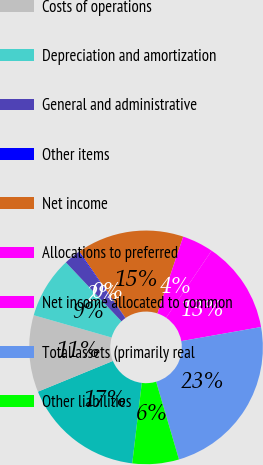Convert chart to OTSL. <chart><loc_0><loc_0><loc_500><loc_500><pie_chart><fcel>Total revenue<fcel>Costs of operations<fcel>Depreciation and amortization<fcel>General and administrative<fcel>Other items<fcel>Net income<fcel>Allocations to preferred<fcel>Net income allocated to common<fcel>Total assets (primarily real<fcel>Other liabilities<nl><fcel>16.93%<fcel>10.63%<fcel>8.53%<fcel>2.23%<fcel>0.13%<fcel>14.83%<fcel>4.33%<fcel>12.73%<fcel>23.24%<fcel>6.43%<nl></chart> 